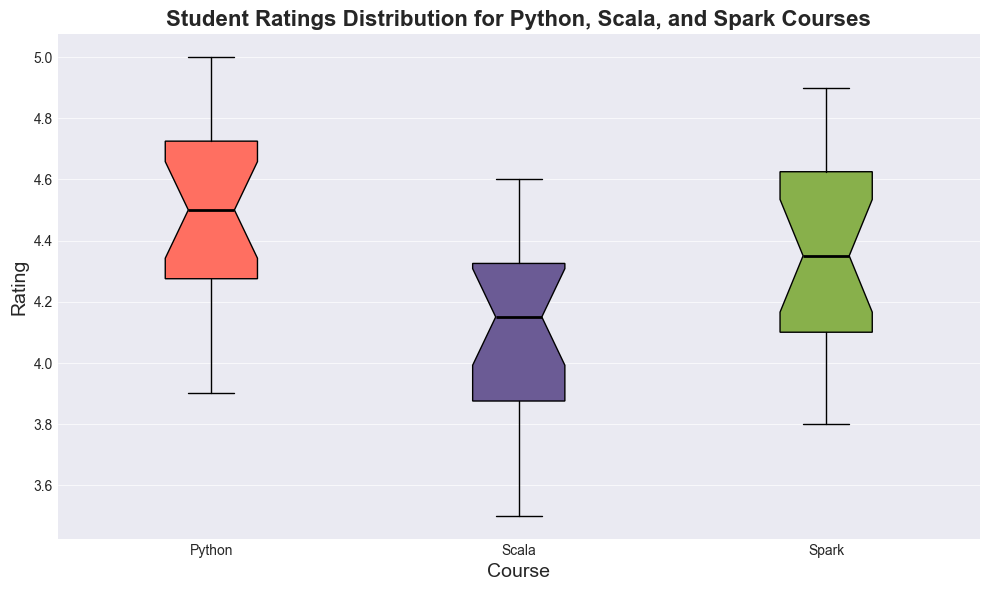What is the median rating for the Python course? To find the median rating for the Python course, look at the middle value of the data series when ordered. The median is represented by the horizontal line within the Python box in the box plot.
Answer: 4.5 Which course has the lowest minimum rating? To determine the course with the lowest minimum rating, look for the bottom whisker of the box plots. The Scala course has the lowest minimum rating.
Answer: Scala What is the interquartile range (IQR) of the Spark course ratings? The IQR is the range between the first quartile (Q1) and the third quartile (Q3). For the Spark course, find the bottom and top of the Spark box: Q1 is about 4.1 and Q3 is approximately 4.7. The IQR is 4.7 - 4.1.
Answer: 0.6 Which course has the highest median rating? To find the course with the highest median rating, compare the horizontal lines inside the boxes of each course. The Spark course has the highest median rating.
Answer: Spark Are the ratings for the Scala course more spread out compared to the Python course? To assess the spread, compare the widths of the boxes (interquartile ranges) and the lengths of the whiskers of the Scala and Python courses. The Scala course has a wider box and longer whiskers than the Python course, indicating a more spread-out distribution.
Answer: Yes Which course has the greatest upper quartile (Q3)? The upper quartile (Q3) is the top line of the box. For this question, compare the top lines of the boxes for each course. The Spark course has the highest Q3.
Answer: Spark Out of Python, Scala, and Spark courses, which course's ratings are the most consistent? To determine consistency, look for the smallest interquartile range (IQR) and shorter whiskers. The Python course has a smaller IQR and shorter whiskers compared to Scala and Spark, indicating more consistent ratings.
Answer: Python What is the range of the ratings for the Python course? The range is the difference between the maximum and minimum ratings. For the Python course, the maximum rating is around 5.0, and the minimum is about 3.9. Subtract 3.9 from 5.0 to find the range.
Answer: 1.1 Which course has the largest number of outlier ratings? Outliers are typically represented by dots outside the whiskers. Count the number of dots for each course. The Python course has the largest number of outlier ratings.
Answer: Python 